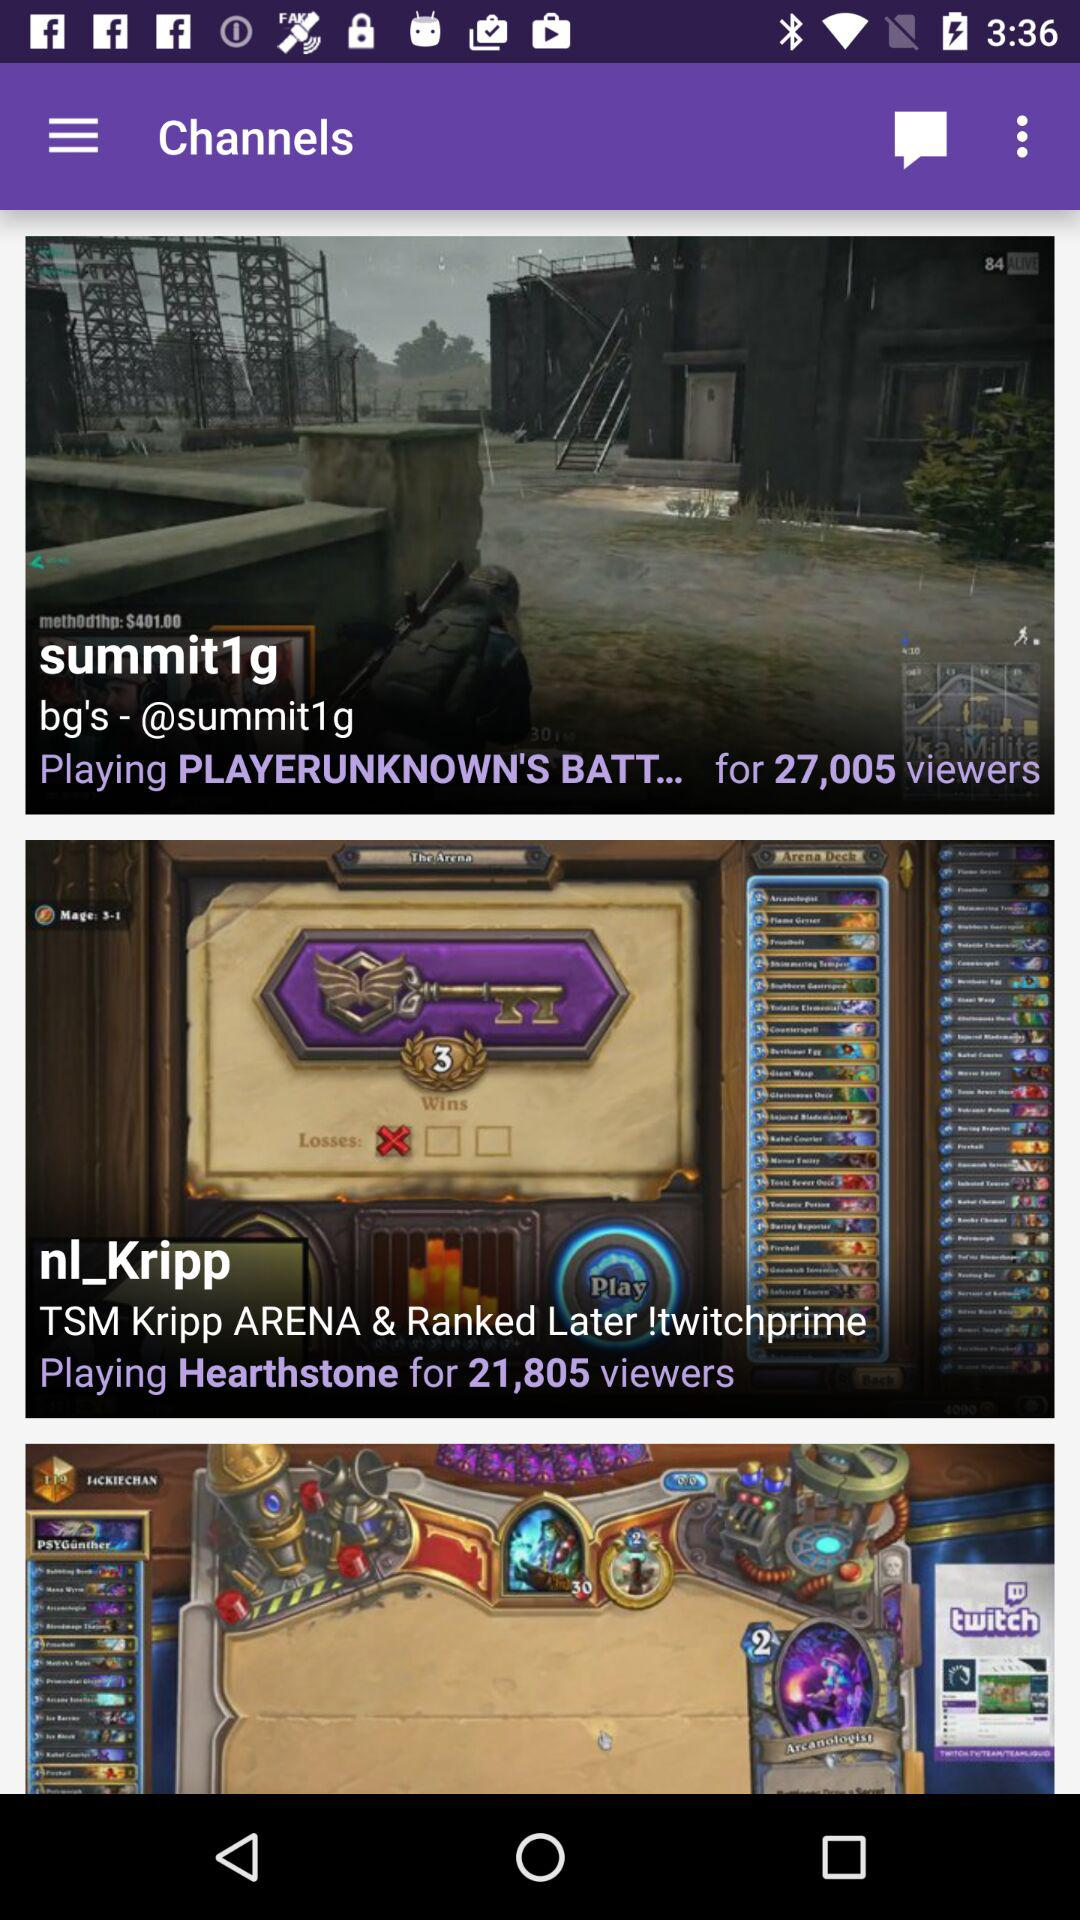What program is running on the channel summit1g? The program running on the channel summit1g is "PLAYERUNKNOWN'S BATT...". 